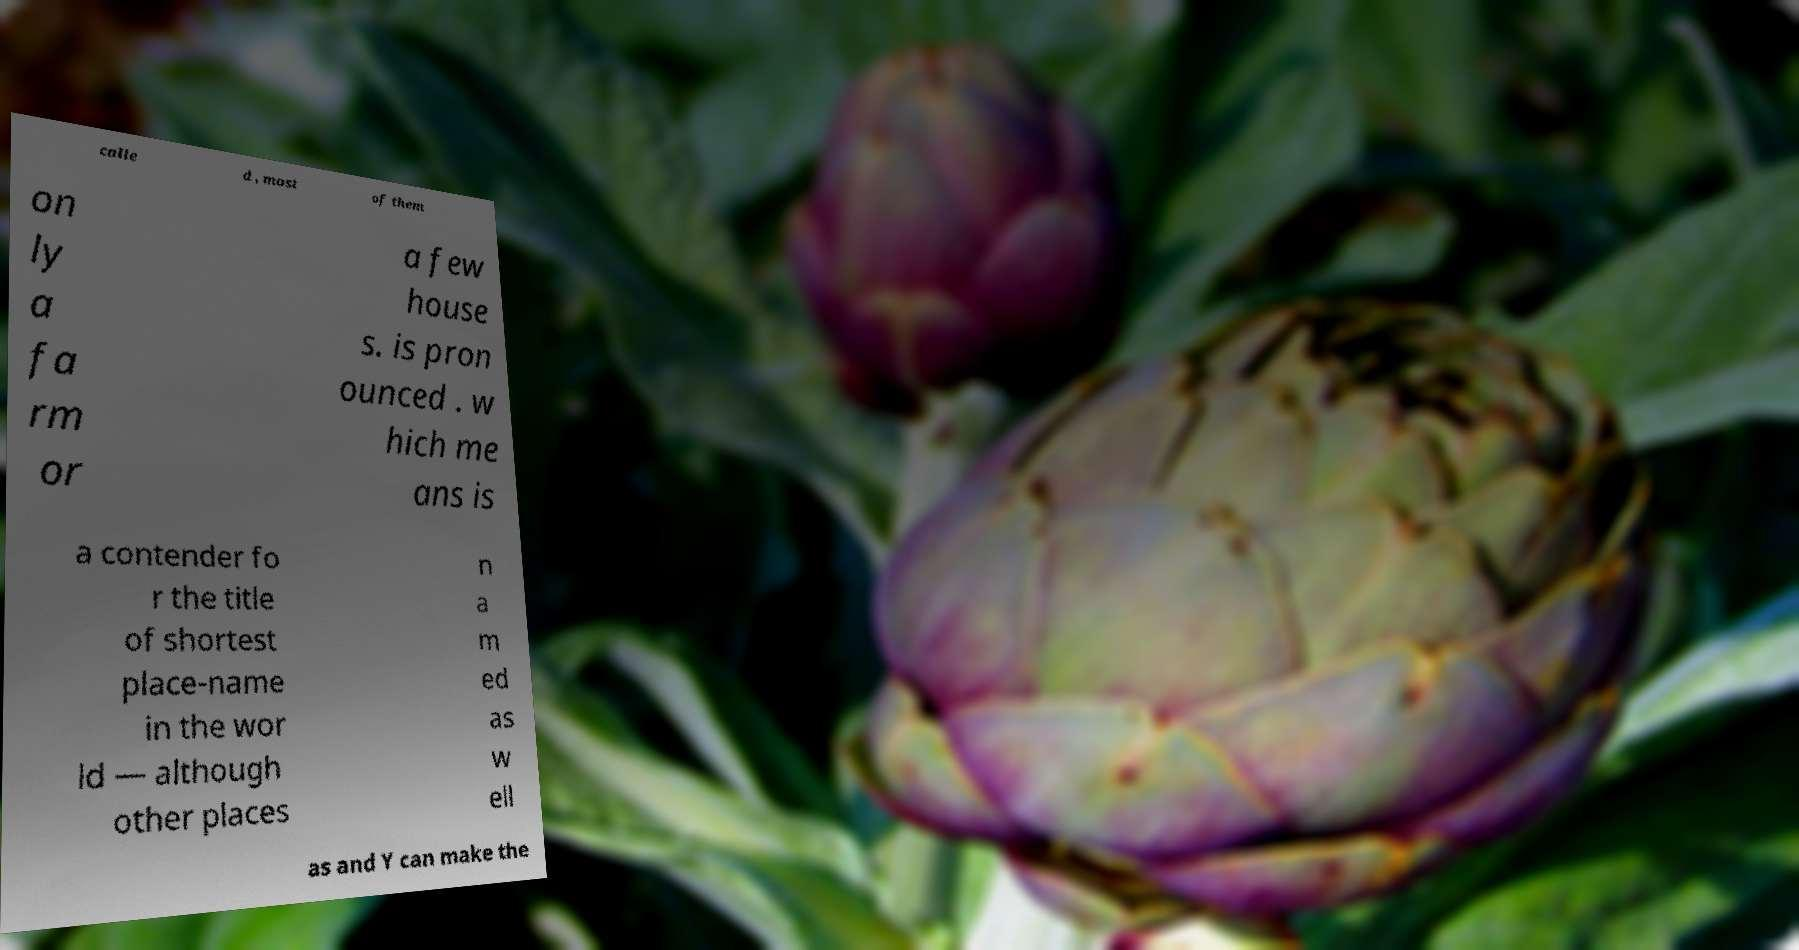Please identify and transcribe the text found in this image. calle d , most of them on ly a fa rm or a few house s. is pron ounced . w hich me ans is a contender fo r the title of shortest place-name in the wor ld — although other places n a m ed as w ell as and Y can make the 